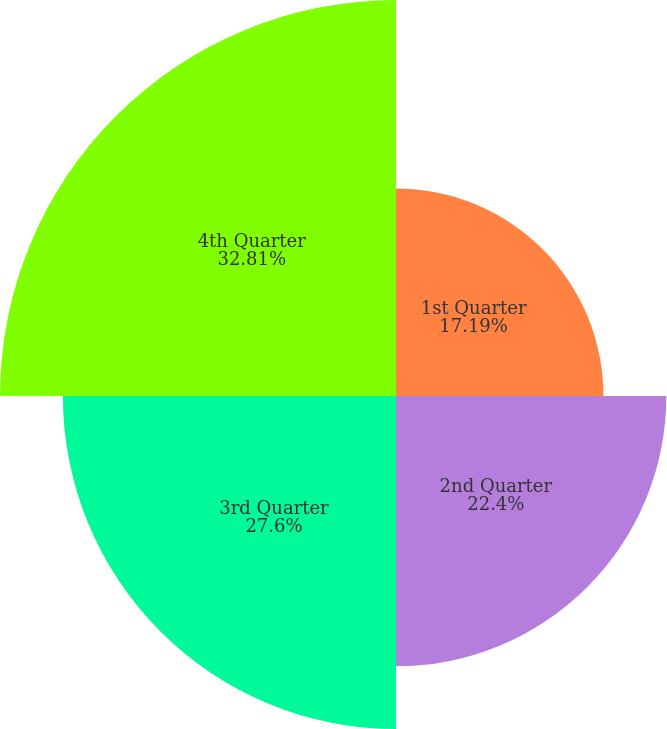<chart> <loc_0><loc_0><loc_500><loc_500><pie_chart><fcel>1st Quarter<fcel>2nd Quarter<fcel>3rd Quarter<fcel>4th Quarter<nl><fcel>17.19%<fcel>22.4%<fcel>27.6%<fcel>32.81%<nl></chart> 